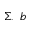<formula> <loc_0><loc_0><loc_500><loc_500>\Sigma , \ b</formula> 